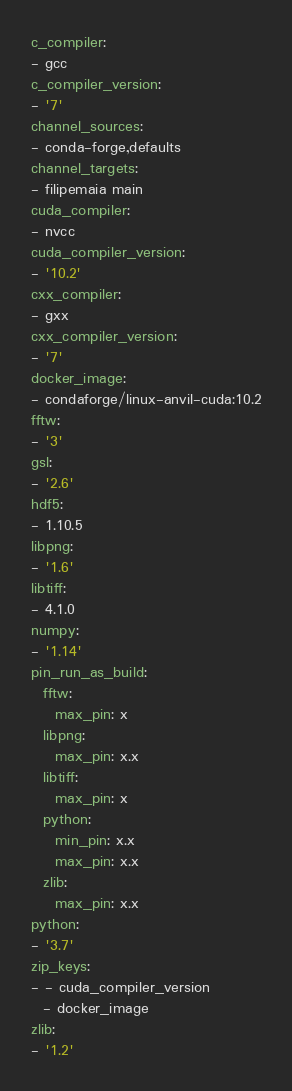<code> <loc_0><loc_0><loc_500><loc_500><_YAML_>c_compiler:
- gcc
c_compiler_version:
- '7'
channel_sources:
- conda-forge,defaults
channel_targets:
- filipemaia main
cuda_compiler:
- nvcc
cuda_compiler_version:
- '10.2'
cxx_compiler:
- gxx
cxx_compiler_version:
- '7'
docker_image:
- condaforge/linux-anvil-cuda:10.2
fftw:
- '3'
gsl:
- '2.6'
hdf5:
- 1.10.5
libpng:
- '1.6'
libtiff:
- 4.1.0
numpy:
- '1.14'
pin_run_as_build:
  fftw:
    max_pin: x
  libpng:
    max_pin: x.x
  libtiff:
    max_pin: x
  python:
    min_pin: x.x
    max_pin: x.x
  zlib:
    max_pin: x.x
python:
- '3.7'
zip_keys:
- - cuda_compiler_version
  - docker_image
zlib:
- '1.2'
</code> 